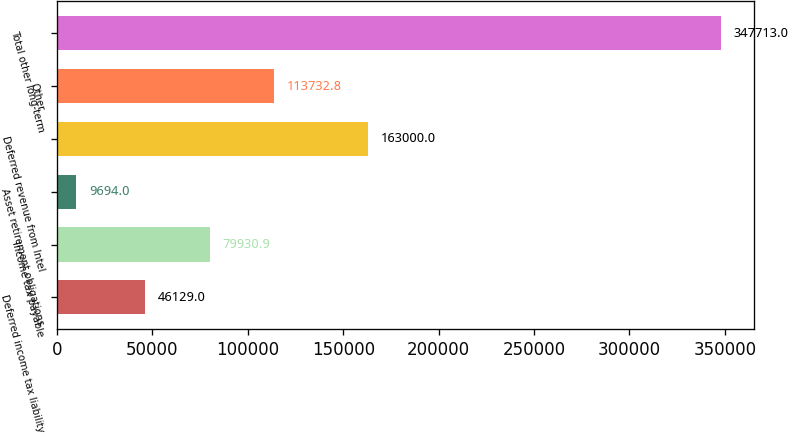Convert chart. <chart><loc_0><loc_0><loc_500><loc_500><bar_chart><fcel>Deferred income tax liability<fcel>Income tax payable<fcel>Asset retirement obligations<fcel>Deferred revenue from Intel<fcel>Other<fcel>Total other long-term<nl><fcel>46129<fcel>79930.9<fcel>9694<fcel>163000<fcel>113733<fcel>347713<nl></chart> 